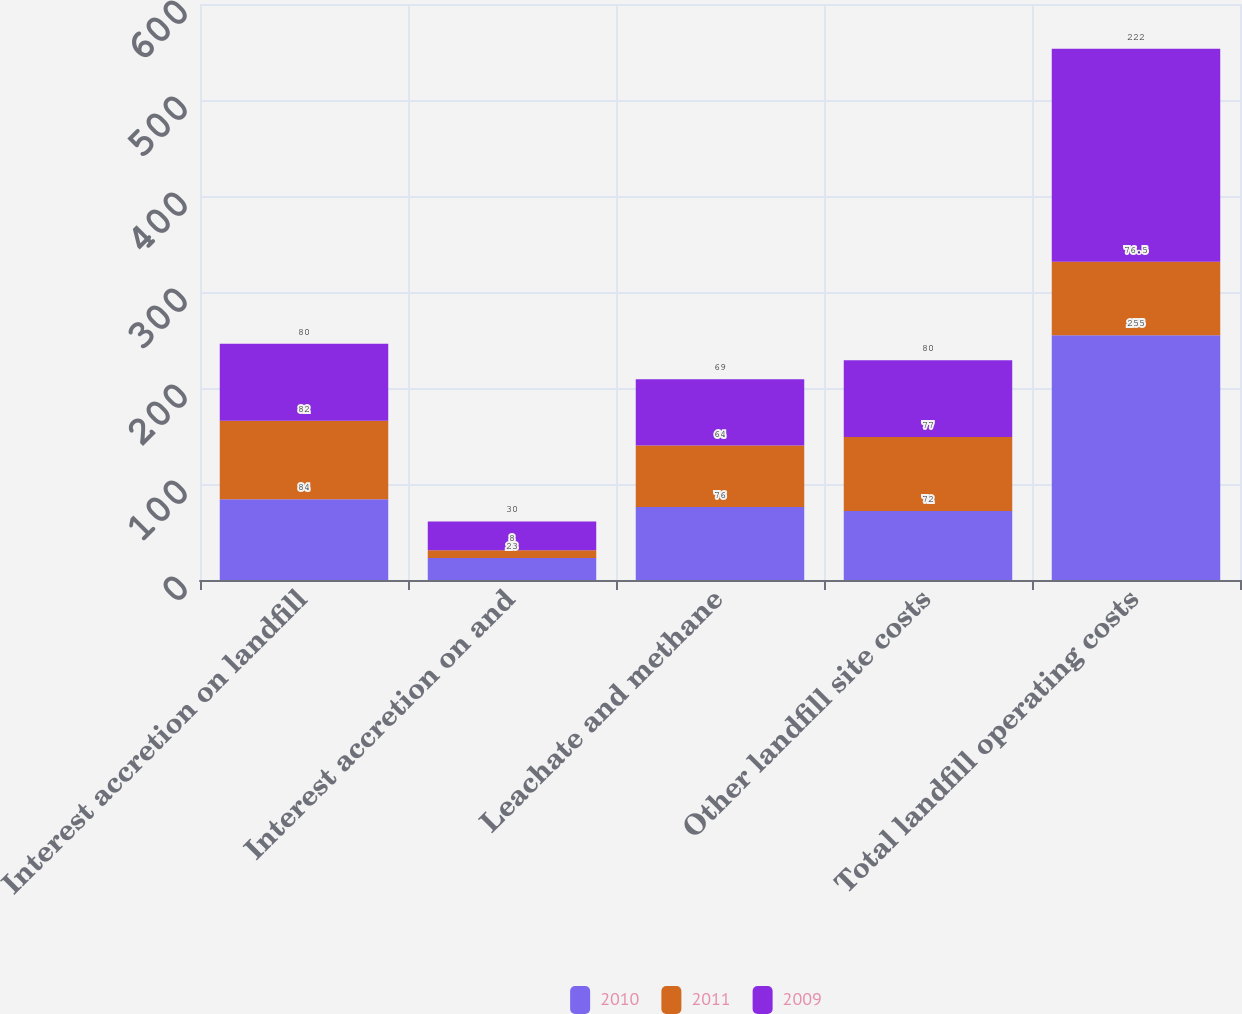Convert chart. <chart><loc_0><loc_0><loc_500><loc_500><stacked_bar_chart><ecel><fcel>Interest accretion on landfill<fcel>Interest accretion on and<fcel>Leachate and methane<fcel>Other landfill site costs<fcel>Total landfill operating costs<nl><fcel>2010<fcel>84<fcel>23<fcel>76<fcel>72<fcel>255<nl><fcel>2011<fcel>82<fcel>8<fcel>64<fcel>77<fcel>76.5<nl><fcel>2009<fcel>80<fcel>30<fcel>69<fcel>80<fcel>222<nl></chart> 